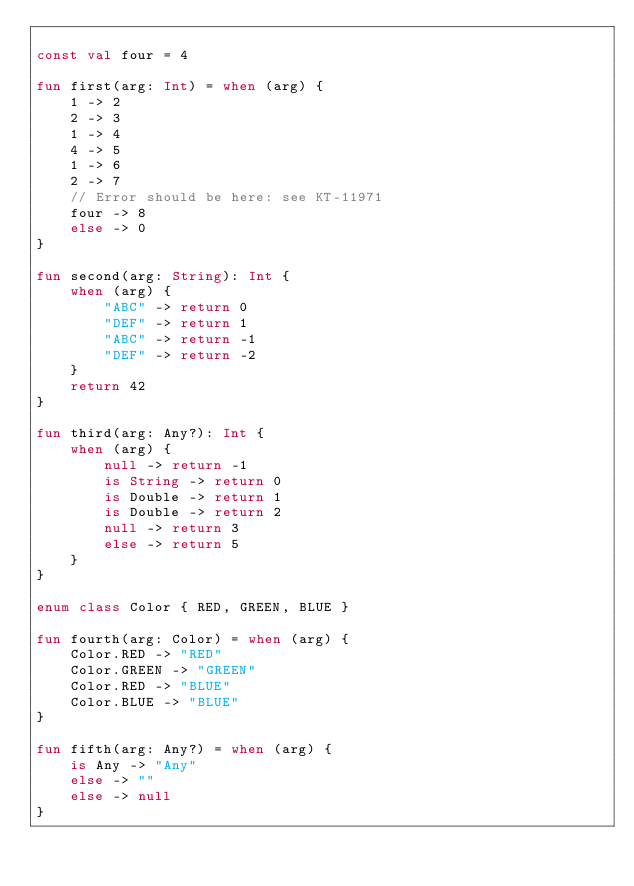Convert code to text. <code><loc_0><loc_0><loc_500><loc_500><_Kotlin_>
const val four = 4

fun first(arg: Int) = when (arg) {
    1 -> 2
    2 -> 3
    1 -> 4
    4 -> 5
    1 -> 6
    2 -> 7
    // Error should be here: see KT-11971
    four -> 8
    else -> 0
}

fun second(arg: String): Int {
    when (arg) {
        "ABC" -> return 0
        "DEF" -> return 1
        "ABC" -> return -1
        "DEF" -> return -2
    }
    return 42
}

fun third(arg: Any?): Int {
    when (arg) {
        null -> return -1
        is String -> return 0
        is Double -> return 1
        is Double -> return 2
        null -> return 3
        else -> return 5
    }
}

enum class Color { RED, GREEN, BLUE }

fun fourth(arg: Color) = when (arg) {
    Color.RED -> "RED"
    Color.GREEN -> "GREEN"
    Color.RED -> "BLUE"
    Color.BLUE -> "BLUE"
}

fun fifth(arg: Any?) = when (arg) {
    is Any -> "Any"
    else -> ""
    else -> null
}
</code> 